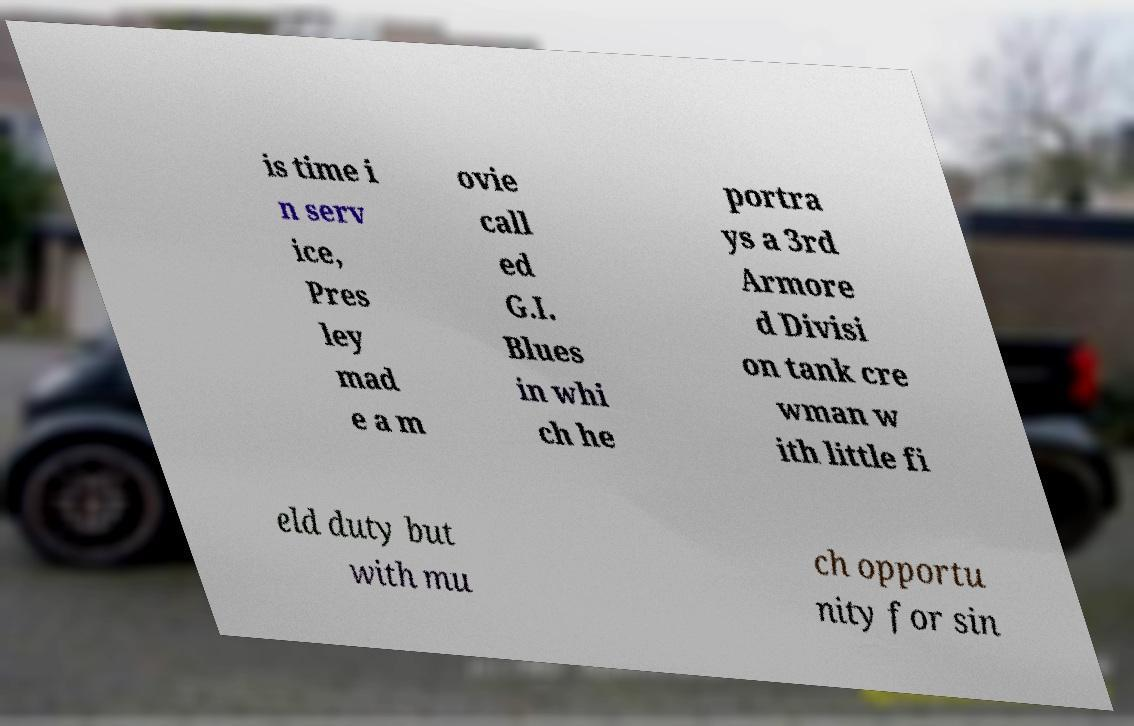There's text embedded in this image that I need extracted. Can you transcribe it verbatim? is time i n serv ice, Pres ley mad e a m ovie call ed G.I. Blues in whi ch he portra ys a 3rd Armore d Divisi on tank cre wman w ith little fi eld duty but with mu ch opportu nity for sin 